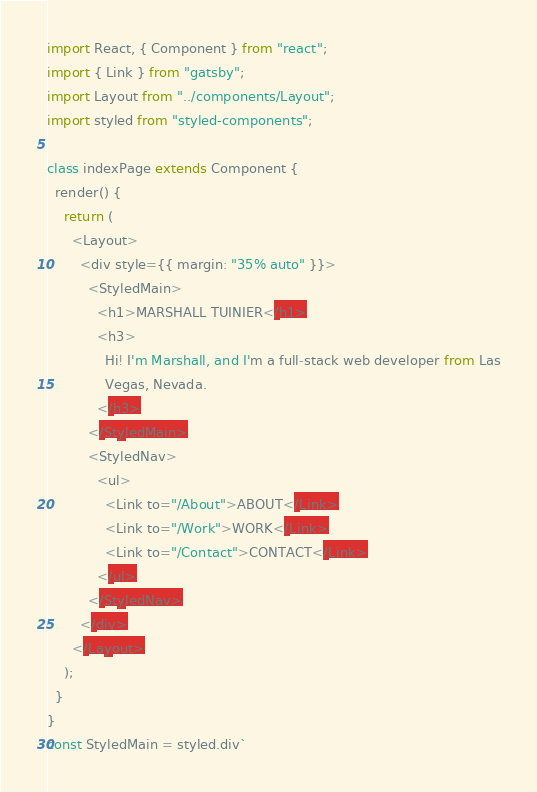<code> <loc_0><loc_0><loc_500><loc_500><_JavaScript_>import React, { Component } from "react";
import { Link } from "gatsby";
import Layout from "../components/Layout";
import styled from "styled-components";

class indexPage extends Component {
  render() {
    return (
      <Layout>
        <div style={{ margin: "35% auto" }}>
          <StyledMain>
            <h1>MARSHALL TUINIER</h1>
            <h3>
              Hi! I'm Marshall, and I'm a full-stack web developer from Las
              Vegas, Nevada.
            </h3>
          </StyledMain>
          <StyledNav>
            <ul>
              <Link to="/About">ABOUT</Link>
              <Link to="/Work">WORK</Link>
              <Link to="/Contact">CONTACT</Link>
            </ul>
          </StyledNav>
        </div>
      </Layout>
    );
  }
}
const StyledMain = styled.div`</code> 